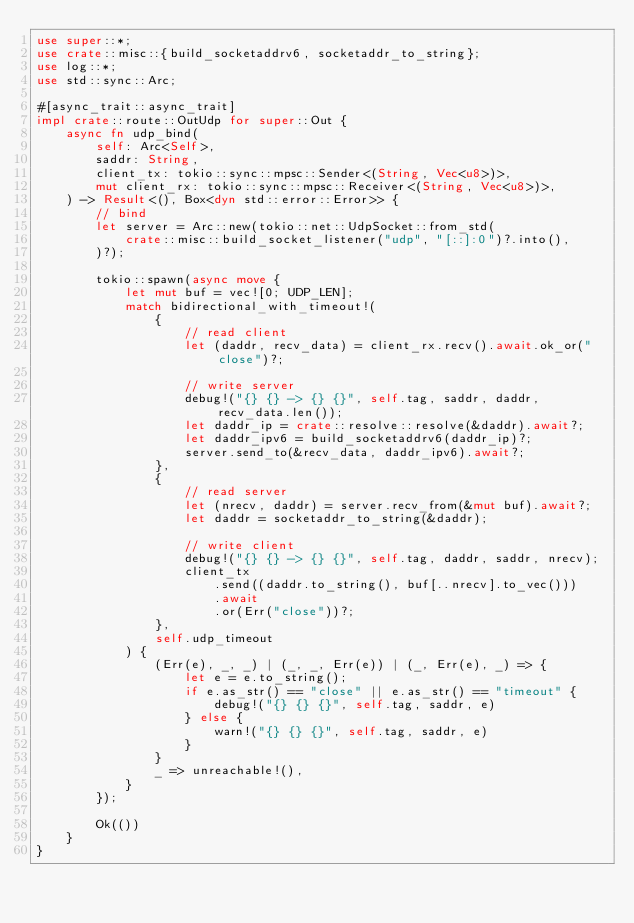<code> <loc_0><loc_0><loc_500><loc_500><_Rust_>use super::*;
use crate::misc::{build_socketaddrv6, socketaddr_to_string};
use log::*;
use std::sync::Arc;

#[async_trait::async_trait]
impl crate::route::OutUdp for super::Out {
    async fn udp_bind(
        self: Arc<Self>,
        saddr: String,
        client_tx: tokio::sync::mpsc::Sender<(String, Vec<u8>)>,
        mut client_rx: tokio::sync::mpsc::Receiver<(String, Vec<u8>)>,
    ) -> Result<(), Box<dyn std::error::Error>> {
        // bind
        let server = Arc::new(tokio::net::UdpSocket::from_std(
            crate::misc::build_socket_listener("udp", "[::]:0")?.into(),
        )?);

        tokio::spawn(async move {
            let mut buf = vec![0; UDP_LEN];
            match bidirectional_with_timeout!(
                {
                    // read client
                    let (daddr, recv_data) = client_rx.recv().await.ok_or("close")?;

                    // write server
                    debug!("{} {} -> {} {}", self.tag, saddr, daddr, recv_data.len());
                    let daddr_ip = crate::resolve::resolve(&daddr).await?;
                    let daddr_ipv6 = build_socketaddrv6(daddr_ip)?;
                    server.send_to(&recv_data, daddr_ipv6).await?;
                },
                {
                    // read server
                    let (nrecv, daddr) = server.recv_from(&mut buf).await?;
                    let daddr = socketaddr_to_string(&daddr);

                    // write client
                    debug!("{} {} -> {} {}", self.tag, daddr, saddr, nrecv);
                    client_tx
                        .send((daddr.to_string(), buf[..nrecv].to_vec()))
                        .await
                        .or(Err("close"))?;
                },
                self.udp_timeout
            ) {
                (Err(e), _, _) | (_, _, Err(e)) | (_, Err(e), _) => {
                    let e = e.to_string();
                    if e.as_str() == "close" || e.as_str() == "timeout" {
                        debug!("{} {} {}", self.tag, saddr, e)
                    } else {
                        warn!("{} {} {}", self.tag, saddr, e)
                    }
                }
                _ => unreachable!(),
            }
        });

        Ok(())
    }
}
</code> 